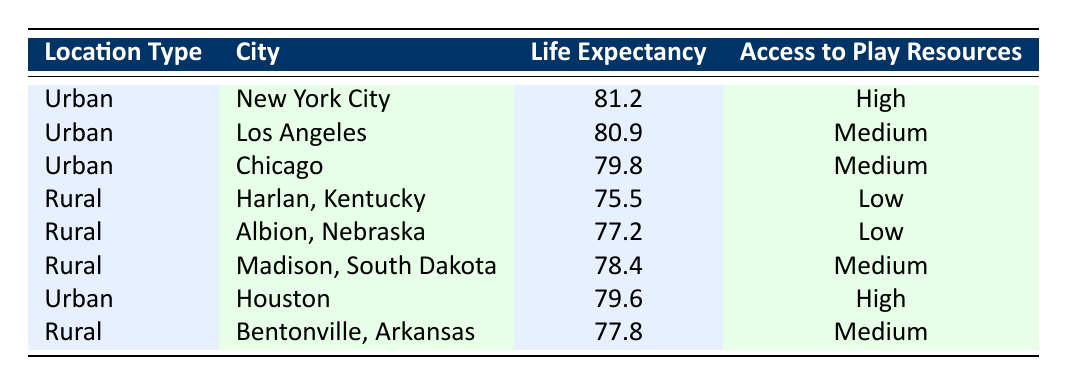What is the life expectancy in New York City? The table lists New York City under the Urban location type, and its life expectancy is given as 81.2 years.
Answer: 81.2 How many cities have high access to play-based learning resources? The table indicates that there are two cities with high access to play resources: New York City and Houston.
Answer: 2 What is the average life expectancy of rural cities listed in the table? The rural cities listed are Harlan, Kentucky (75.5), Albion, Nebraska (77.2), Madison, South Dakota (78.4), and Bentonville, Arkansas (77.8). Adding these gives 75.5 + 77.2 + 78.4 + 77.8 = 309. The average is 309/4 = 77.25.
Answer: 77.25 Is it true that all urban cities have a higher life expectancy than rural cities? Comparing the life expectancies, urban cities have life expectancies of 81.2, 80.9, 79.8, and 79.6 while rural cities have 75.5, 77.2, 78.4, and 77.8. All urban life expectancies are higher than the highest rural life expectancy of 78.4.
Answer: Yes Which urban city has the lowest life expectancy? From the urban cities presented, Chicago has the lowest life expectancy at 79.8.
Answer: Chicago What is the difference in life expectancy between the city with the highest and lowest scores in the table? The city with the highest life expectancy is New York City at 81.2, and the lowest is Harlan, Kentucky at 75.5. The difference is 81.2 - 75.5 = 5.7.
Answer: 5.7 Are there any cities in the table with medium access to play resources that also have a life expectancy under 80? The cities with medium access to play resources are Los Angeles (80.9), Chicago (79.8), Madison (78.4), and Bentonville (77.8). Among these, Chicago (79.8) and Bentonville (77.8) have life expectancies under 80.
Answer: Yes Which type of location (urban or rural) has a higher average life expectancy? The average life expectancy for urban cities is (81.2 + 80.9 + 79.8 + 79.6)/4 = 80.375. For rural cities, it is (75.5 + 77.2 + 78.4 + 77.8)/4 = 77.25. Since 80.375 is greater than 77.25, urban locations have a higher average life expectancy.
Answer: Urban 